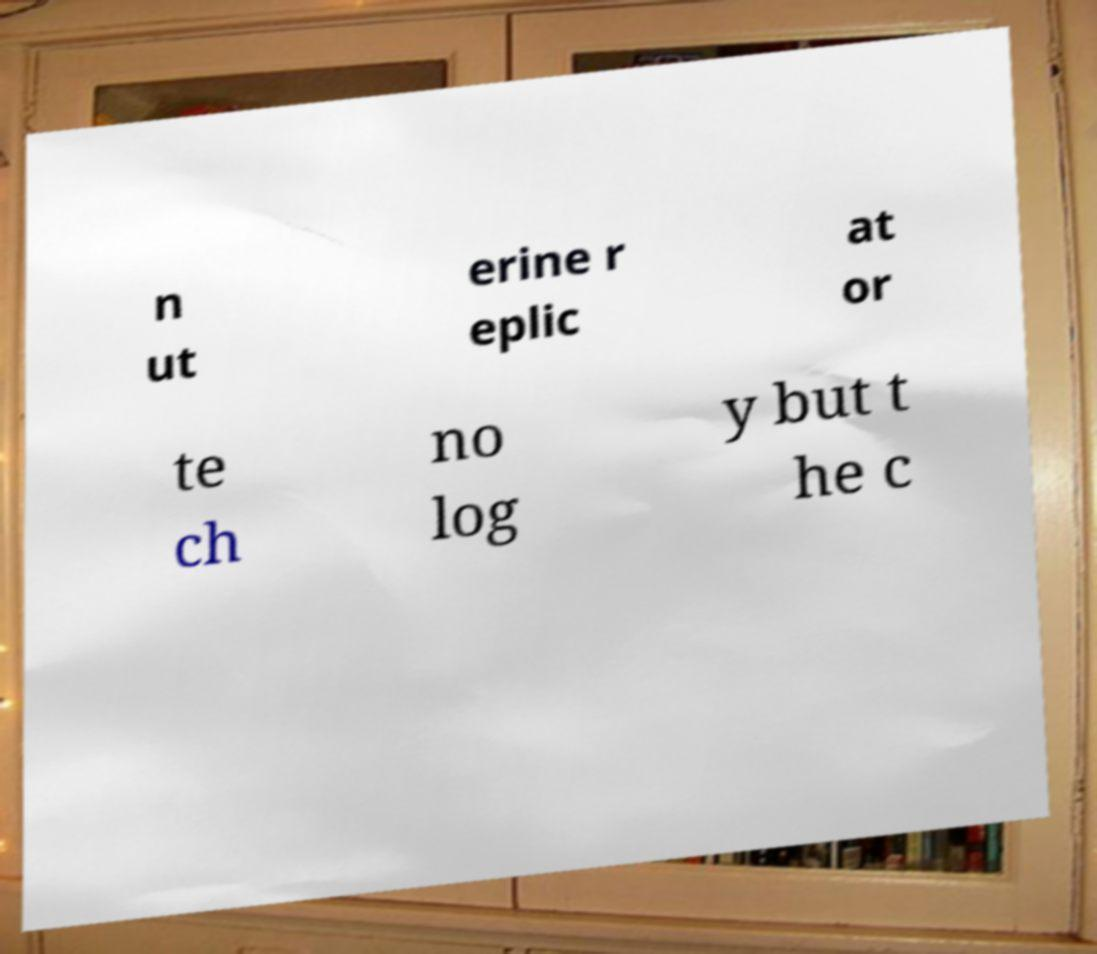There's text embedded in this image that I need extracted. Can you transcribe it verbatim? n ut erine r eplic at or te ch no log y but t he c 